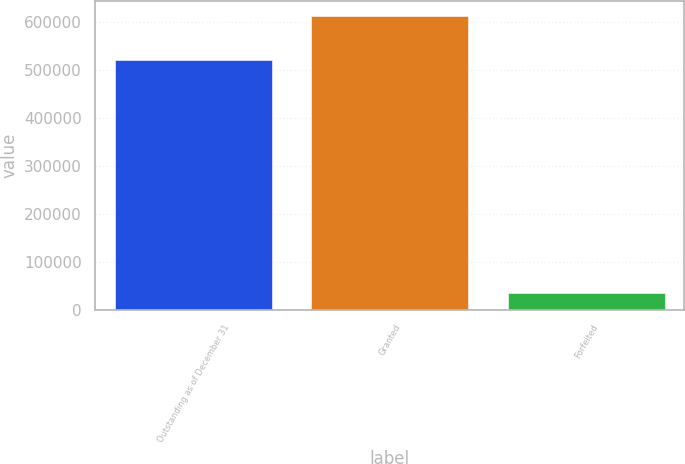Convert chart. <chart><loc_0><loc_0><loc_500><loc_500><bar_chart><fcel>Outstanding as of December 31<fcel>Granted<fcel>Forfeited<nl><fcel>520762<fcel>613570<fcel>35249<nl></chart> 